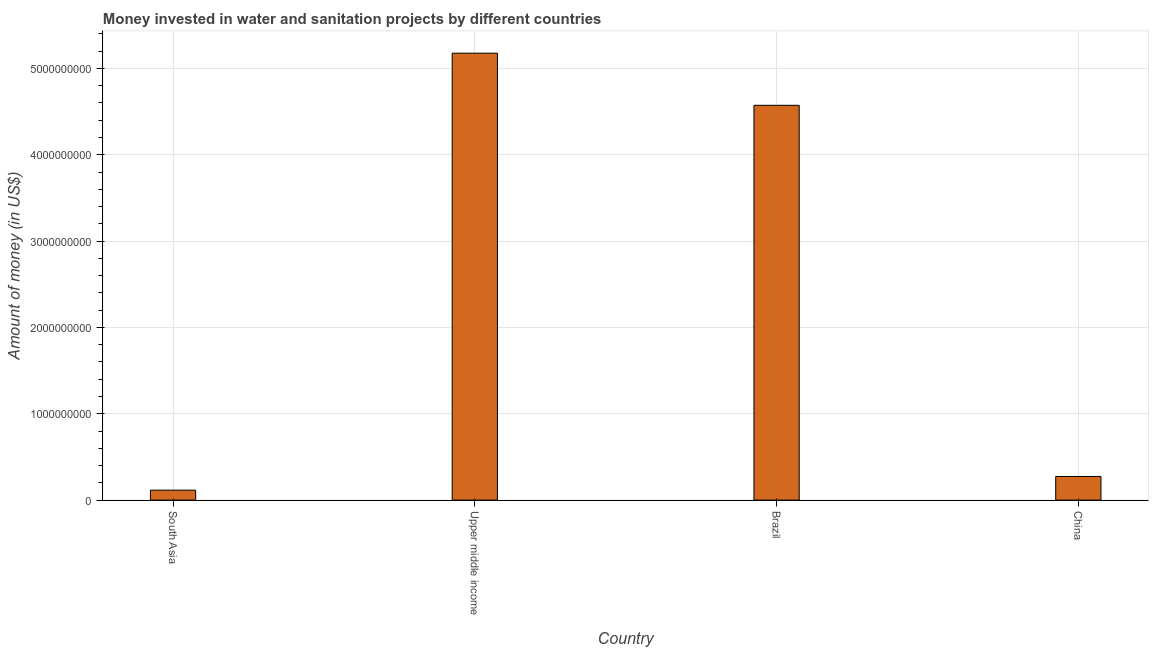What is the title of the graph?
Your response must be concise. Money invested in water and sanitation projects by different countries. What is the label or title of the Y-axis?
Your answer should be very brief. Amount of money (in US$). What is the investment in China?
Your answer should be very brief. 2.74e+08. Across all countries, what is the maximum investment?
Offer a terse response. 5.18e+09. Across all countries, what is the minimum investment?
Make the answer very short. 1.16e+08. In which country was the investment maximum?
Offer a very short reply. Upper middle income. What is the sum of the investment?
Make the answer very short. 1.01e+1. What is the difference between the investment in Brazil and South Asia?
Provide a short and direct response. 4.46e+09. What is the average investment per country?
Offer a terse response. 2.53e+09. What is the median investment?
Provide a short and direct response. 2.42e+09. What is the ratio of the investment in China to that in Upper middle income?
Your answer should be compact. 0.05. Is the difference between the investment in Brazil and South Asia greater than the difference between any two countries?
Offer a terse response. No. What is the difference between the highest and the second highest investment?
Provide a short and direct response. 6.04e+08. What is the difference between the highest and the lowest investment?
Make the answer very short. 5.06e+09. In how many countries, is the investment greater than the average investment taken over all countries?
Keep it short and to the point. 2. How many countries are there in the graph?
Your response must be concise. 4. What is the Amount of money (in US$) in South Asia?
Keep it short and to the point. 1.16e+08. What is the Amount of money (in US$) of Upper middle income?
Give a very brief answer. 5.18e+09. What is the Amount of money (in US$) of Brazil?
Make the answer very short. 4.57e+09. What is the Amount of money (in US$) in China?
Your response must be concise. 2.74e+08. What is the difference between the Amount of money (in US$) in South Asia and Upper middle income?
Your response must be concise. -5.06e+09. What is the difference between the Amount of money (in US$) in South Asia and Brazil?
Make the answer very short. -4.46e+09. What is the difference between the Amount of money (in US$) in South Asia and China?
Provide a succinct answer. -1.58e+08. What is the difference between the Amount of money (in US$) in Upper middle income and Brazil?
Provide a succinct answer. 6.04e+08. What is the difference between the Amount of money (in US$) in Upper middle income and China?
Give a very brief answer. 4.90e+09. What is the difference between the Amount of money (in US$) in Brazil and China?
Offer a very short reply. 4.30e+09. What is the ratio of the Amount of money (in US$) in South Asia to that in Upper middle income?
Keep it short and to the point. 0.02. What is the ratio of the Amount of money (in US$) in South Asia to that in Brazil?
Keep it short and to the point. 0.03. What is the ratio of the Amount of money (in US$) in South Asia to that in China?
Make the answer very short. 0.42. What is the ratio of the Amount of money (in US$) in Upper middle income to that in Brazil?
Provide a succinct answer. 1.13. What is the ratio of the Amount of money (in US$) in Upper middle income to that in China?
Your answer should be compact. 18.89. What is the ratio of the Amount of money (in US$) in Brazil to that in China?
Your response must be concise. 16.69. 